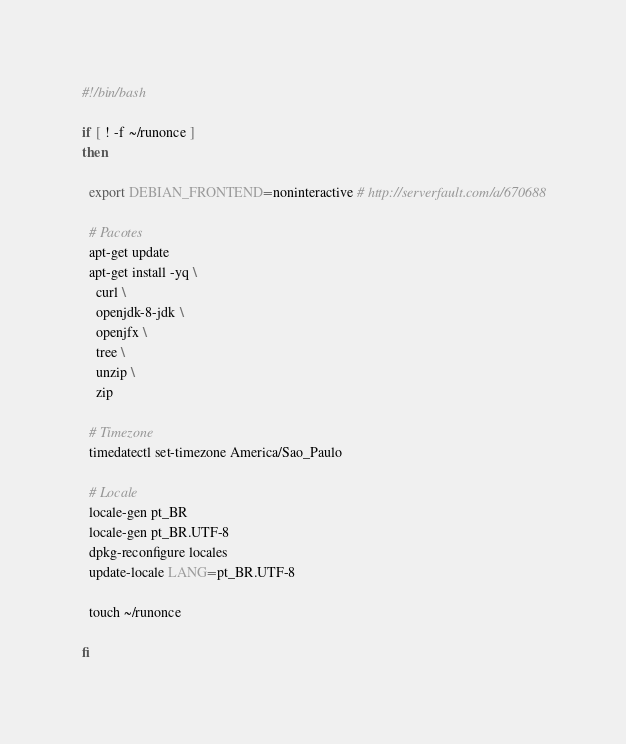<code> <loc_0><loc_0><loc_500><loc_500><_Bash_>#!/bin/bash

if [ ! -f ~/runonce ]
then

  export DEBIAN_FRONTEND=noninteractive # http://serverfault.com/a/670688

  # Pacotes
  apt-get update
  apt-get install -yq \
    curl \
    openjdk-8-jdk \
    openjfx \
    tree \
    unzip \
    zip

  # Timezone
  timedatectl set-timezone America/Sao_Paulo

  # Locale
  locale-gen pt_BR
  locale-gen pt_BR.UTF-8
  dpkg-reconfigure locales
  update-locale LANG=pt_BR.UTF-8

  touch ~/runonce

fi</code> 